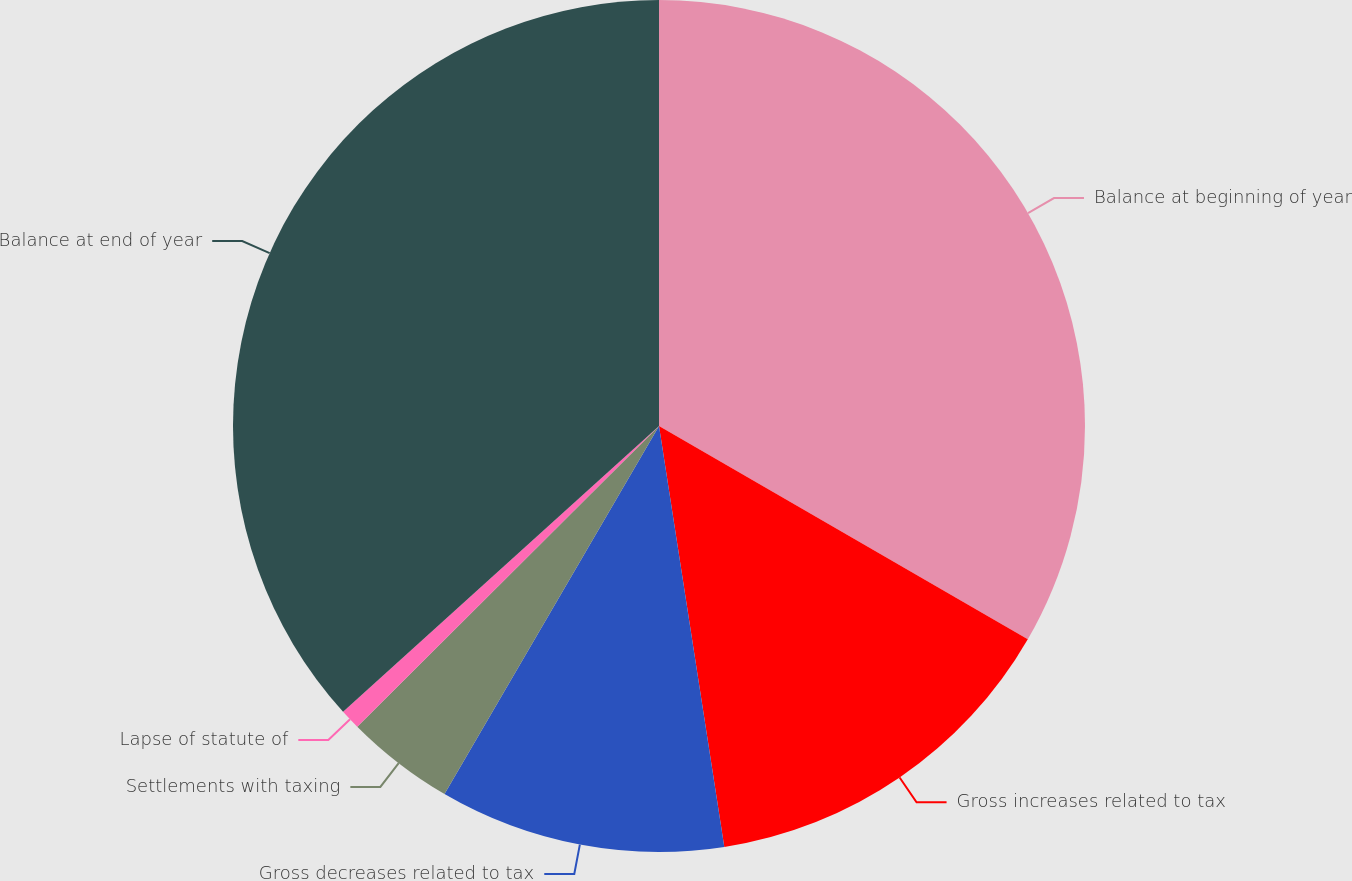Convert chart. <chart><loc_0><loc_0><loc_500><loc_500><pie_chart><fcel>Balance at beginning of year<fcel>Gross increases related to tax<fcel>Gross decreases related to tax<fcel>Settlements with taxing<fcel>Lapse of statute of<fcel>Balance at end of year<nl><fcel>33.35%<fcel>14.21%<fcel>10.85%<fcel>4.13%<fcel>0.77%<fcel>36.71%<nl></chart> 